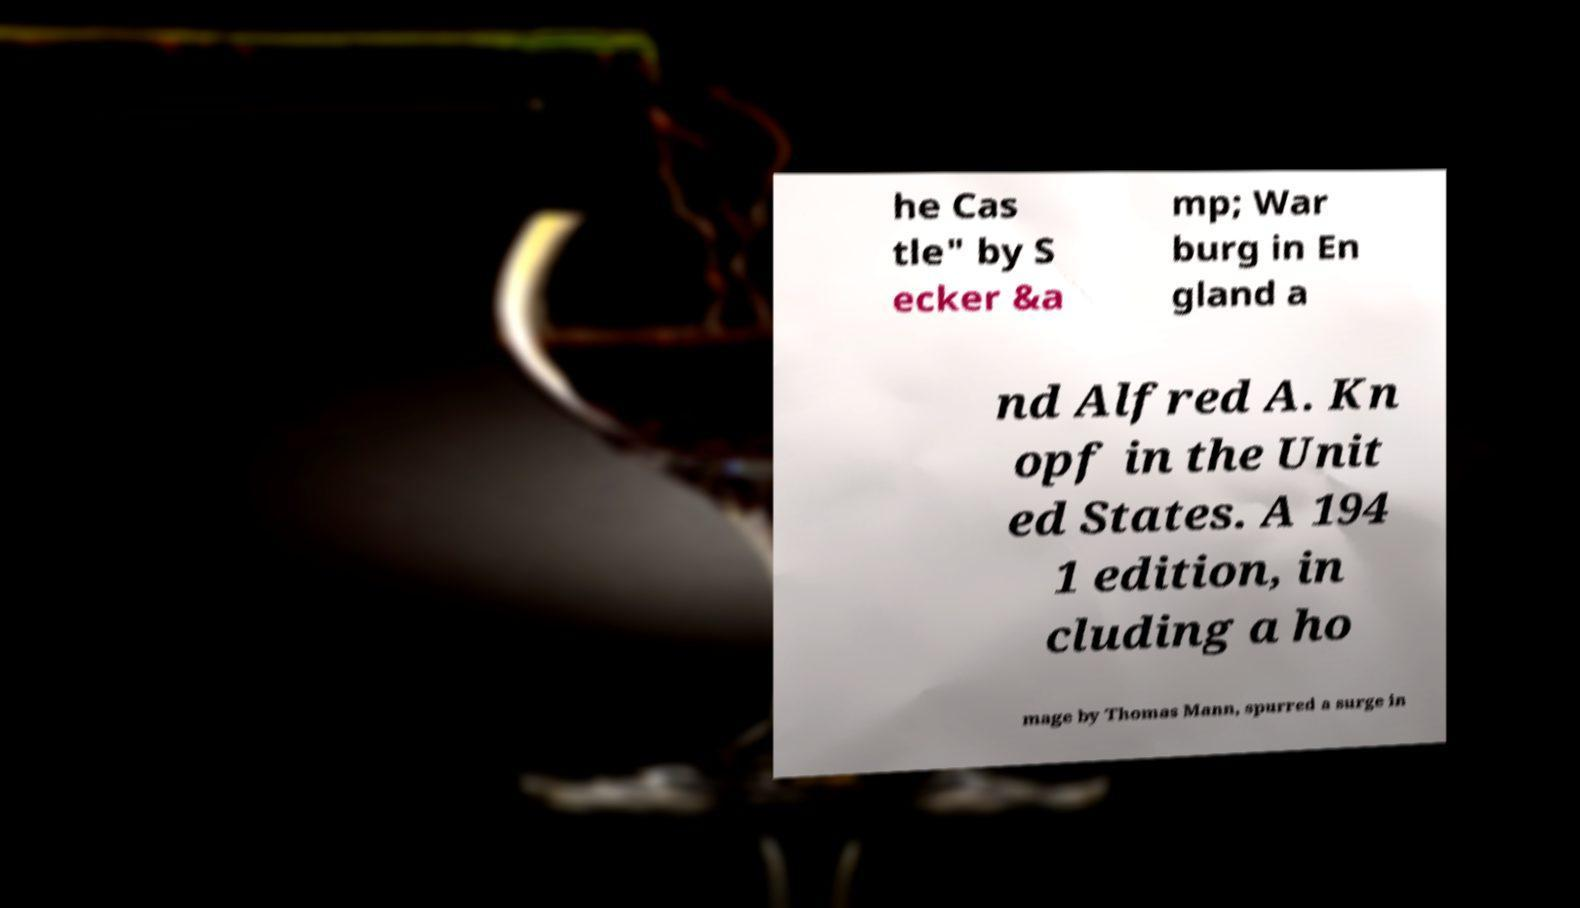Can you accurately transcribe the text from the provided image for me? he Cas tle" by S ecker &a mp; War burg in En gland a nd Alfred A. Kn opf in the Unit ed States. A 194 1 edition, in cluding a ho mage by Thomas Mann, spurred a surge in 